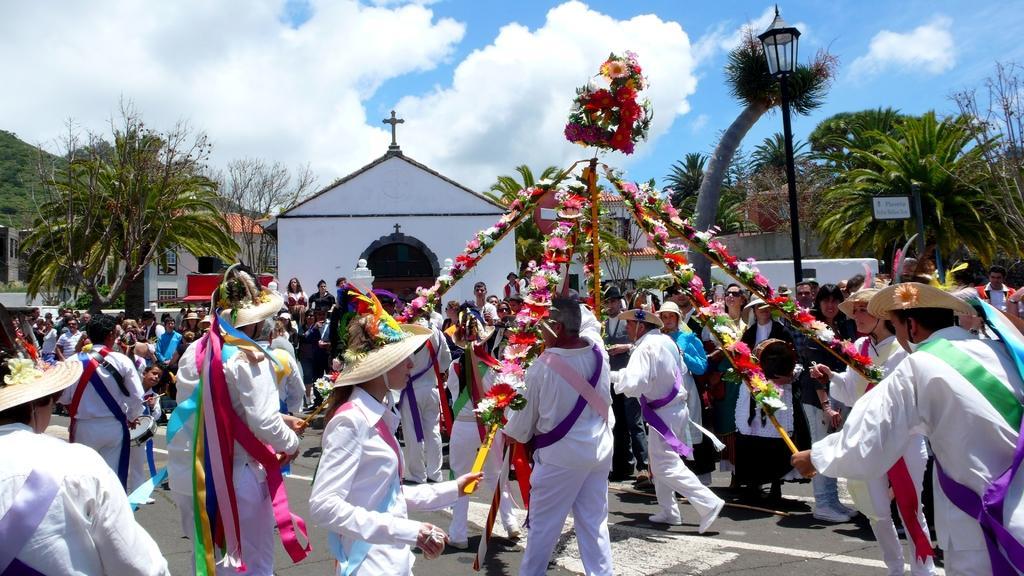In one or two sentences, can you explain what this image depicts? In the middle of the picture, we see the group of people who are wearing the same costumes are standing. They are holding the wooden stick which is decorated with flowers. They might be playing. Behind them, we see people are standing. Behind them, we see a light pole. There are trees and buildings in the background. In the middle, we see the church. On the left side, we see the hills. 